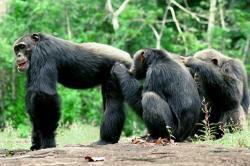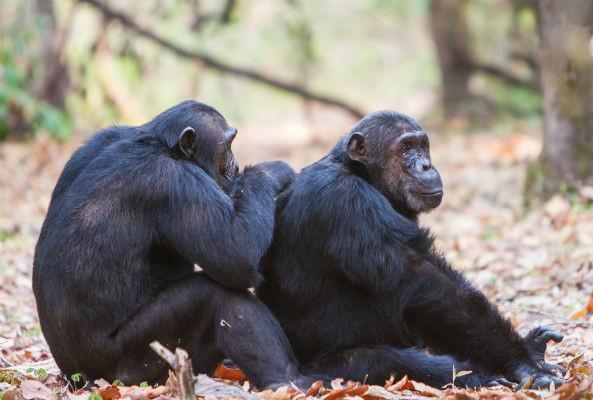The first image is the image on the left, the second image is the image on the right. Assess this claim about the two images: "There are exactly three gorillas huddled together in the image on the left.". Correct or not? Answer yes or no. Yes. The first image is the image on the left, the second image is the image on the right. Analyze the images presented: Is the assertion "An image shows two rightward-facing apes, with one sitting behind the other." valid? Answer yes or no. Yes. 